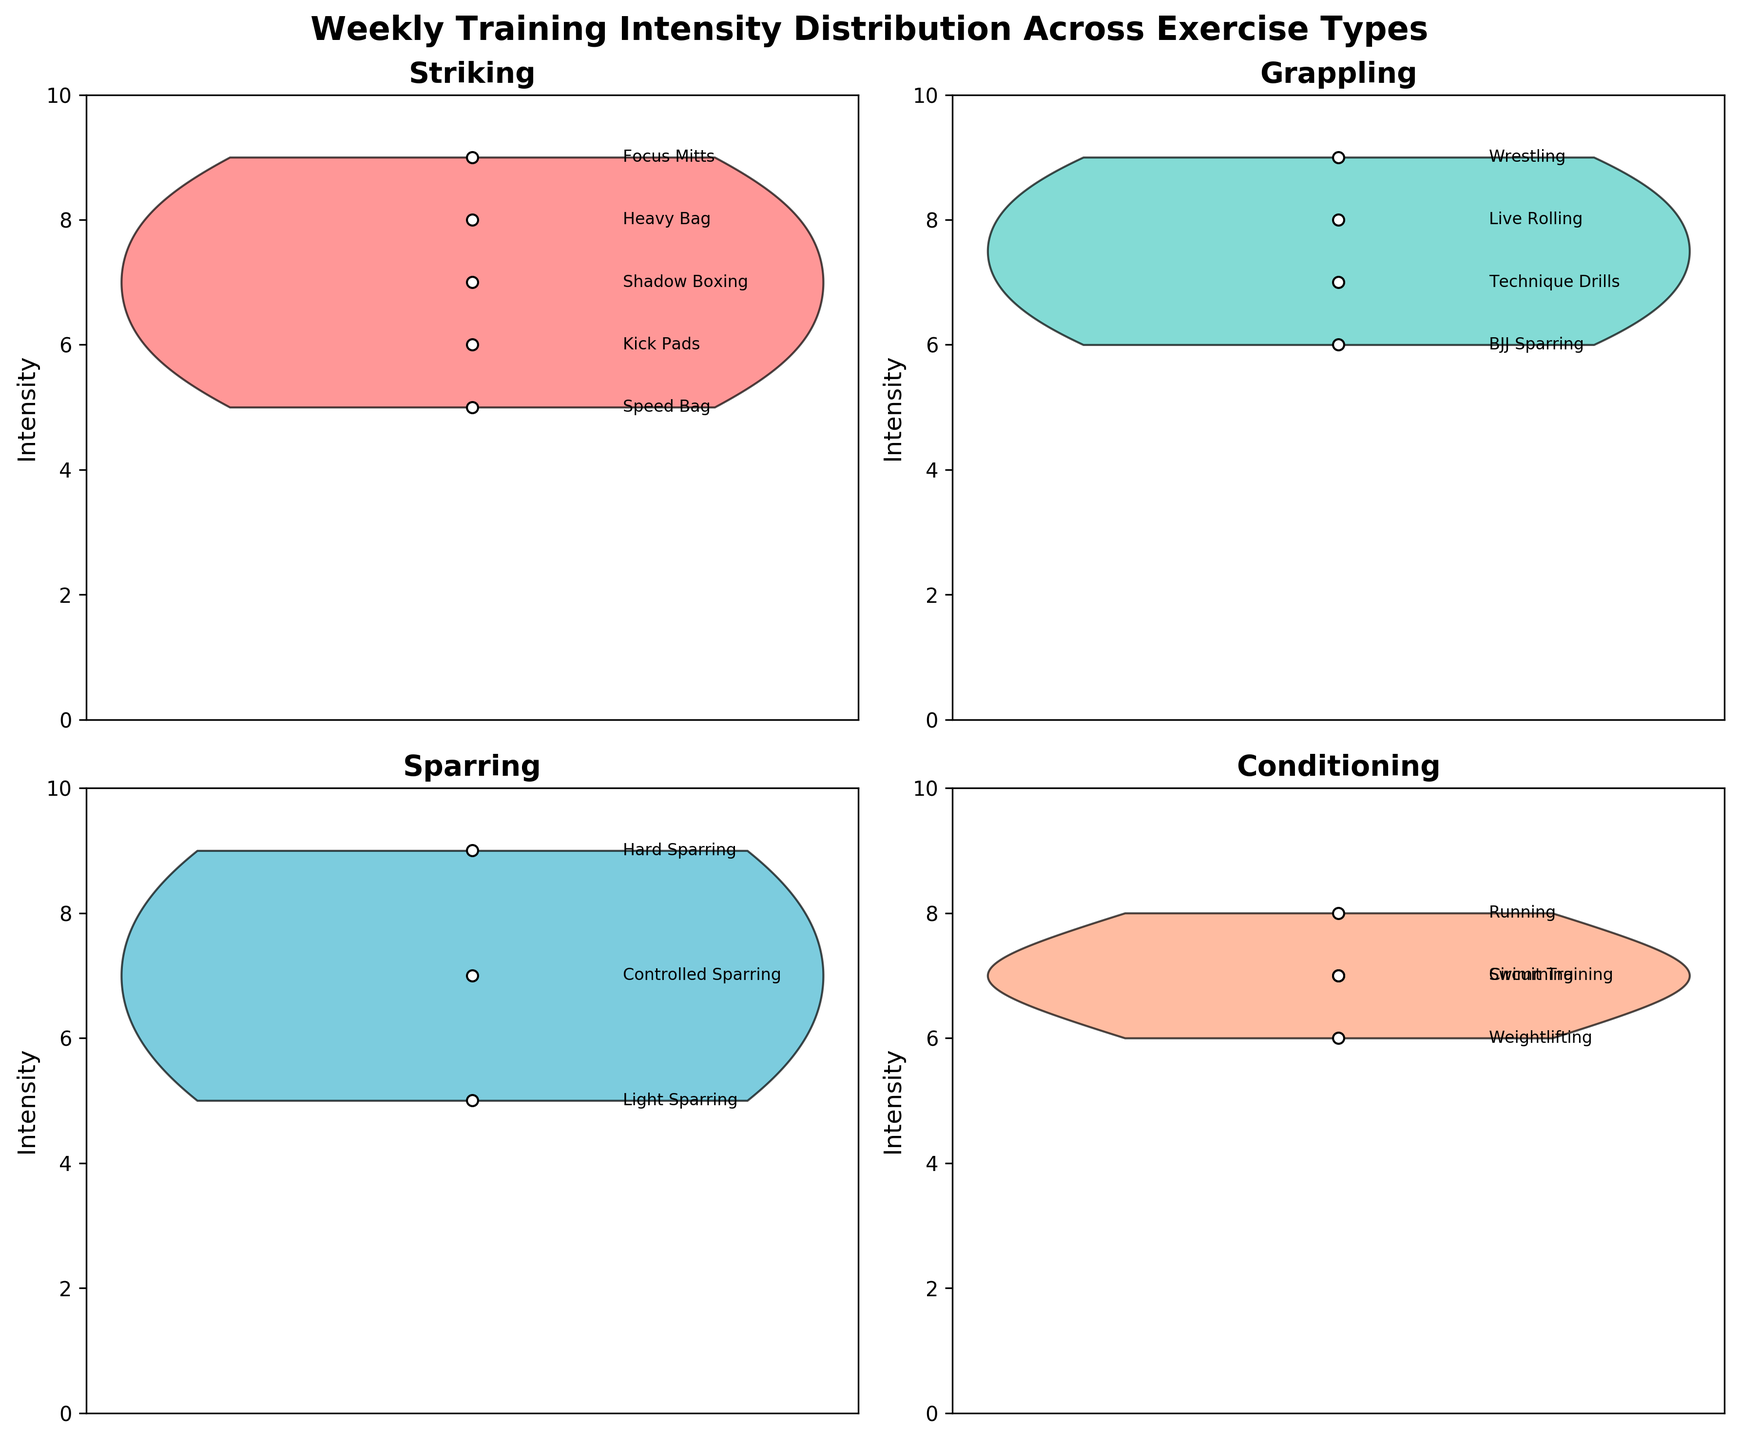Which exercise type has the lowest maximum intensity? By looking at each subplot, the maximum intensity is represented by the top of the highest violin plot. Conditioning seems to have a maximum intensity of 8, which is lower than the other exercise types.
Answer: Conditioning What is the title of the figure? The title is displayed at the top of the figure, usually in a larger and bold font. It reads "Weekly Training Intensity Distribution Across Exercise Types."
Answer: Weekly Training Intensity Distribution Across Exercise Types How many exercise types are displayed in the figure? Each subplot represents a different exercise type. Counting the subplots, we see there are four: Striking, Grappling, Sparring, and Conditioning.
Answer: 4 Compare the median intensities of Striking and Sparring. Which is higher? To find the median, we look for the value that separates the higher half from the lower half. In the Striking subplot, focus mitts have an intensity of 9, while in Sparring, hard sparring also has an intensity of 9. Both have similar high points, but the overall distribution makes it clearer that Sparring generally has a higher concentration of higher intensity values.
Answer: Sparring Which exercise type shows the most consistent intensity? Consistency here refers to less spread or variability in the intensity values within a particular exercise type. The Conditioning subplot shows intensities of 6, 7, and 8, which indicates a lower spread compared to others.
Answer: Conditioning Which training type within Sparring has the highest intensity? Within the Sparring subplot, the annotations for each data point indicate the training types and their corresponding intensities. Hard Sparring has an intensity of 9, which is higher than the others.
Answer: Hard Sparring What are the intensity values for the heaviest peaks in Grappling? The Grappling subplot has peaks at different intensity values. Live Rolling (8), Technique Drills (7), Wrestling (9), and BJJ Sparring (6).
Answer: 8, 7, 9, 6 Compare the highest and lowest intensities observed in Striking. What is the range? The highest intensity in Striking is from Focus Mitts at 9, and the lowest is from Speed Bag at 5. The range is calculated as the difference between the highest and lowest values: 9 - 5 = 4.
Answer: 4 